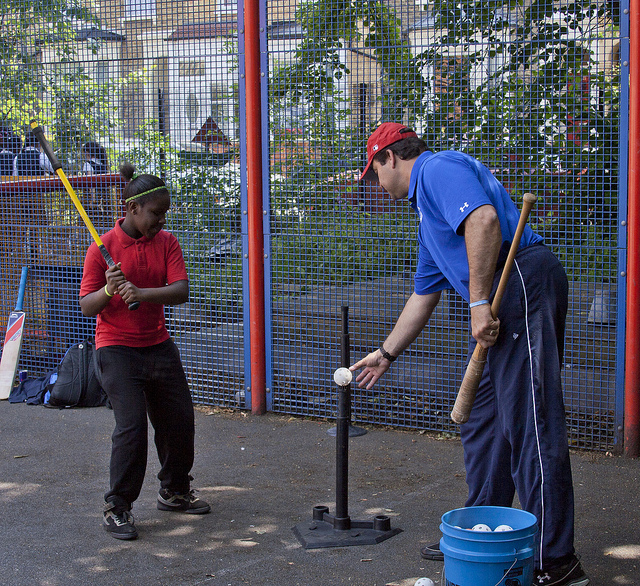Extract all visible text content from this image. H 